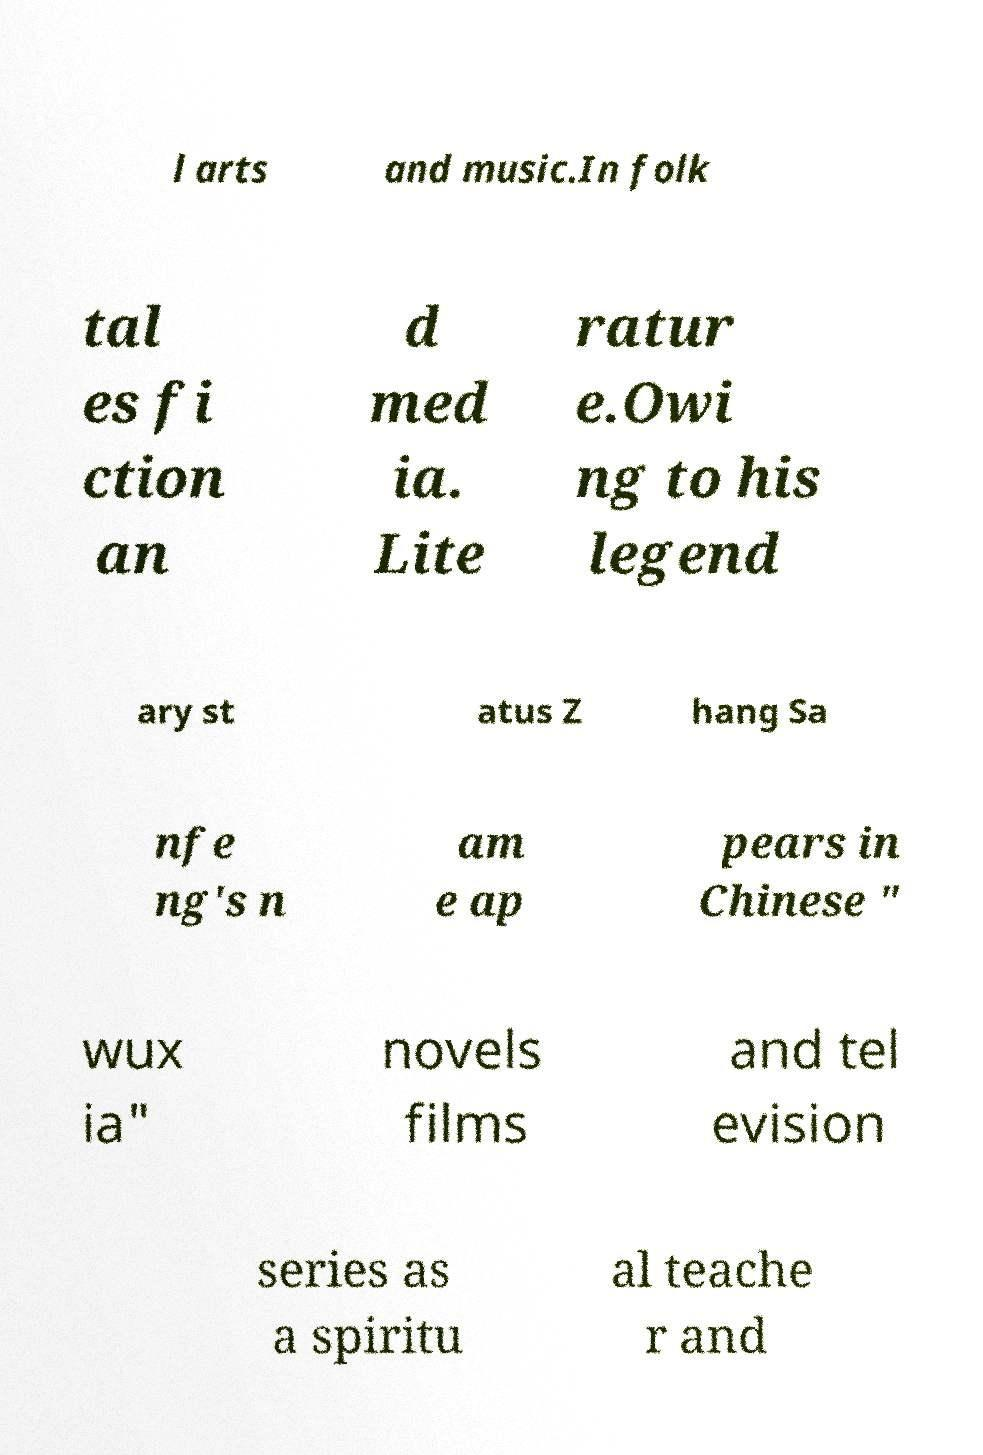Can you read and provide the text displayed in the image?This photo seems to have some interesting text. Can you extract and type it out for me? l arts and music.In folk tal es fi ction an d med ia. Lite ratur e.Owi ng to his legend ary st atus Z hang Sa nfe ng's n am e ap pears in Chinese " wux ia" novels films and tel evision series as a spiritu al teache r and 